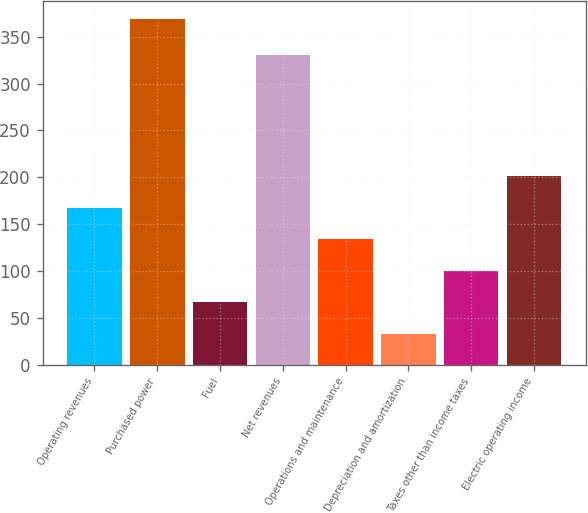<chart> <loc_0><loc_0><loc_500><loc_500><bar_chart><fcel>Operating revenues<fcel>Purchased power<fcel>Fuel<fcel>Net revenues<fcel>Operations and maintenance<fcel>Depreciation and amortization<fcel>Taxes other than income taxes<fcel>Electric operating income<nl><fcel>167.4<fcel>369<fcel>66.6<fcel>330<fcel>133.8<fcel>33<fcel>100.2<fcel>201<nl></chart> 